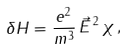Convert formula to latex. <formula><loc_0><loc_0><loc_500><loc_500>\delta H = \frac { e ^ { 2 } } { m ^ { 3 } } \, \vec { E } ^ { \, 2 } \, \chi \, ,</formula> 